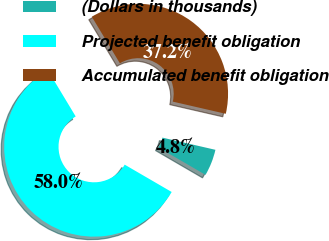<chart> <loc_0><loc_0><loc_500><loc_500><pie_chart><fcel>(Dollars in thousands)<fcel>Projected benefit obligation<fcel>Accumulated benefit obligation<nl><fcel>4.79%<fcel>57.98%<fcel>37.23%<nl></chart> 